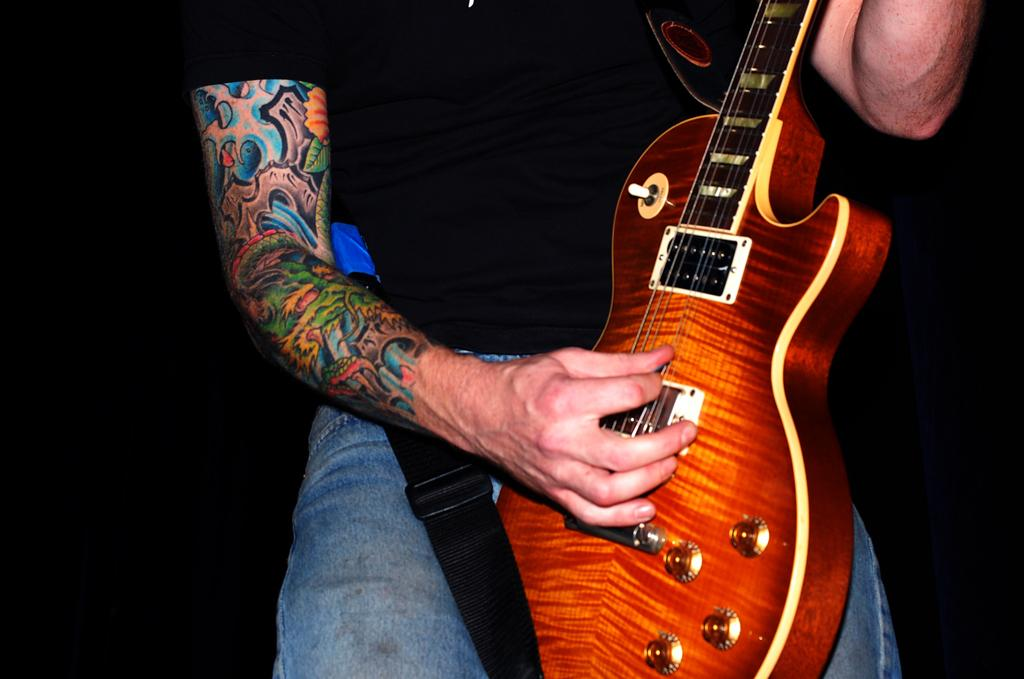Who is the main subject in the image? There is a man in the center of the image. What is the man holding in the image? The man is holding a guitar. Can you describe any additional details about the man? The man has a tattoo on his hand. How many dogs are present in the image? There are no dogs present in the image; it features a man holding a guitar. What type of mountain can be seen in the background of the image? There is no mountain present in the image; it only features a man holding a guitar. 